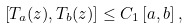<formula> <loc_0><loc_0><loc_500><loc_500>\left [ T _ { a } ( z ) , T _ { b } ( z ) \right ] \leq C _ { 1 } \left [ a , b \right ] ,</formula> 